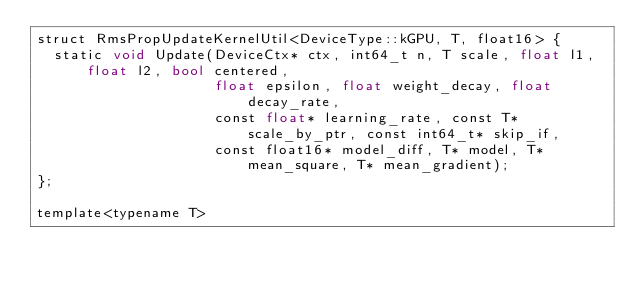<code> <loc_0><loc_0><loc_500><loc_500><_Cuda_>struct RmsPropUpdateKernelUtil<DeviceType::kGPU, T, float16> {
  static void Update(DeviceCtx* ctx, int64_t n, T scale, float l1, float l2, bool centered,
                     float epsilon, float weight_decay, float decay_rate,
                     const float* learning_rate, const T* scale_by_ptr, const int64_t* skip_if,
                     const float16* model_diff, T* model, T* mean_square, T* mean_gradient);
};

template<typename T></code> 